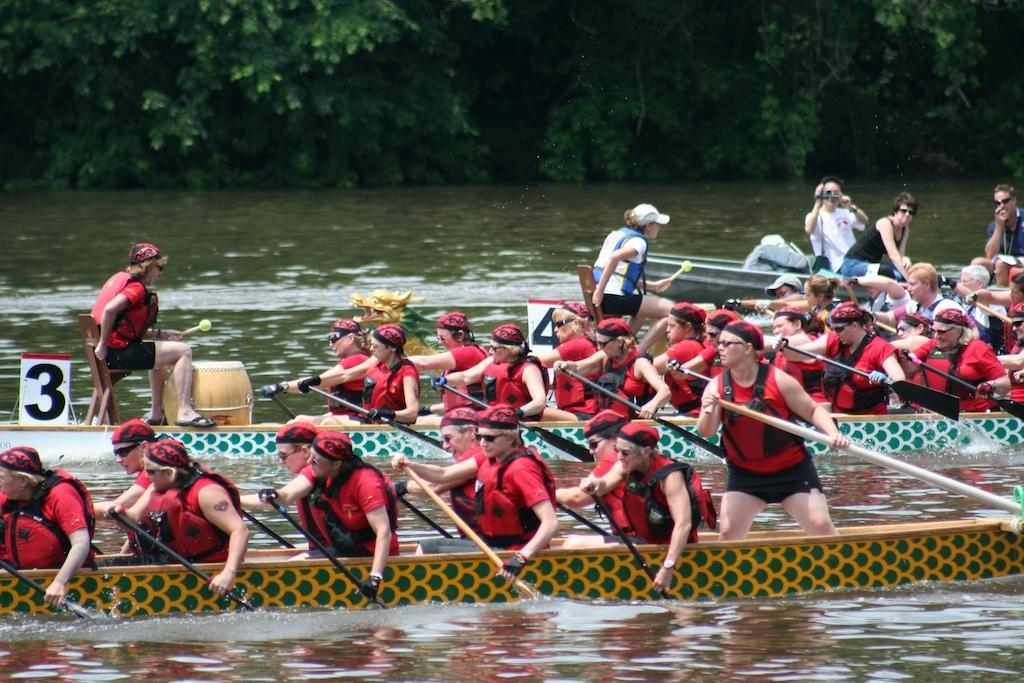Who or what can be seen in the image? There are people in the image. What are the people doing in the image? The people are boating on the surface of the water. What is the primary element in the image? There is water visible in the image. What can be seen in the background of the image? There are trees in the background of the image. What type of appliance can be seen on the sidewalk in the image? There is no sidewalk or appliance present in the image. 